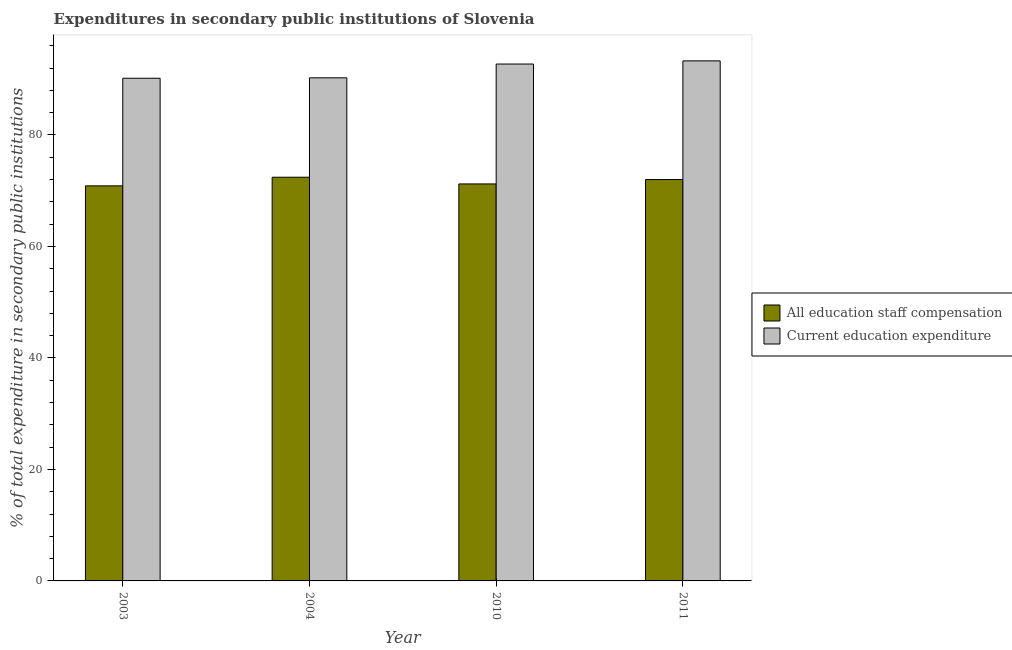How many bars are there on the 4th tick from the left?
Offer a terse response. 2. What is the label of the 2nd group of bars from the left?
Your response must be concise. 2004. In how many cases, is the number of bars for a given year not equal to the number of legend labels?
Your response must be concise. 0. What is the expenditure in staff compensation in 2010?
Your answer should be very brief. 71.22. Across all years, what is the maximum expenditure in education?
Give a very brief answer. 93.3. Across all years, what is the minimum expenditure in staff compensation?
Provide a short and direct response. 70.87. In which year was the expenditure in education maximum?
Your answer should be very brief. 2011. What is the total expenditure in education in the graph?
Your answer should be very brief. 366.46. What is the difference between the expenditure in staff compensation in 2003 and that in 2011?
Ensure brevity in your answer.  -1.14. What is the difference between the expenditure in education in 2003 and the expenditure in staff compensation in 2011?
Provide a short and direct response. -3.12. What is the average expenditure in staff compensation per year?
Make the answer very short. 71.63. In the year 2011, what is the difference between the expenditure in staff compensation and expenditure in education?
Make the answer very short. 0. What is the ratio of the expenditure in education in 2004 to that in 2011?
Provide a short and direct response. 0.97. What is the difference between the highest and the second highest expenditure in staff compensation?
Offer a very short reply. 0.42. What is the difference between the highest and the lowest expenditure in staff compensation?
Your answer should be very brief. 1.55. What does the 2nd bar from the left in 2010 represents?
Provide a short and direct response. Current education expenditure. What does the 1st bar from the right in 2003 represents?
Provide a short and direct response. Current education expenditure. Are all the bars in the graph horizontal?
Offer a very short reply. No. What is the difference between two consecutive major ticks on the Y-axis?
Provide a succinct answer. 20. Where does the legend appear in the graph?
Keep it short and to the point. Center right. How are the legend labels stacked?
Your answer should be very brief. Vertical. What is the title of the graph?
Offer a very short reply. Expenditures in secondary public institutions of Slovenia. What is the label or title of the X-axis?
Ensure brevity in your answer.  Year. What is the label or title of the Y-axis?
Make the answer very short. % of total expenditure in secondary public institutions. What is the % of total expenditure in secondary public institutions in All education staff compensation in 2003?
Your response must be concise. 70.87. What is the % of total expenditure in secondary public institutions in Current education expenditure in 2003?
Provide a short and direct response. 90.18. What is the % of total expenditure in secondary public institutions of All education staff compensation in 2004?
Your answer should be compact. 72.42. What is the % of total expenditure in secondary public institutions in Current education expenditure in 2004?
Make the answer very short. 90.26. What is the % of total expenditure in secondary public institutions of All education staff compensation in 2010?
Your response must be concise. 71.22. What is the % of total expenditure in secondary public institutions of Current education expenditure in 2010?
Provide a short and direct response. 92.73. What is the % of total expenditure in secondary public institutions in All education staff compensation in 2011?
Give a very brief answer. 72.01. What is the % of total expenditure in secondary public institutions in Current education expenditure in 2011?
Keep it short and to the point. 93.3. Across all years, what is the maximum % of total expenditure in secondary public institutions in All education staff compensation?
Make the answer very short. 72.42. Across all years, what is the maximum % of total expenditure in secondary public institutions in Current education expenditure?
Your response must be concise. 93.3. Across all years, what is the minimum % of total expenditure in secondary public institutions of All education staff compensation?
Ensure brevity in your answer.  70.87. Across all years, what is the minimum % of total expenditure in secondary public institutions in Current education expenditure?
Your answer should be very brief. 90.18. What is the total % of total expenditure in secondary public institutions of All education staff compensation in the graph?
Offer a very short reply. 286.52. What is the total % of total expenditure in secondary public institutions of Current education expenditure in the graph?
Ensure brevity in your answer.  366.46. What is the difference between the % of total expenditure in secondary public institutions in All education staff compensation in 2003 and that in 2004?
Provide a succinct answer. -1.55. What is the difference between the % of total expenditure in secondary public institutions in Current education expenditure in 2003 and that in 2004?
Your answer should be very brief. -0.08. What is the difference between the % of total expenditure in secondary public institutions of All education staff compensation in 2003 and that in 2010?
Offer a very short reply. -0.35. What is the difference between the % of total expenditure in secondary public institutions of Current education expenditure in 2003 and that in 2010?
Make the answer very short. -2.55. What is the difference between the % of total expenditure in secondary public institutions in All education staff compensation in 2003 and that in 2011?
Give a very brief answer. -1.14. What is the difference between the % of total expenditure in secondary public institutions in Current education expenditure in 2003 and that in 2011?
Your response must be concise. -3.12. What is the difference between the % of total expenditure in secondary public institutions in All education staff compensation in 2004 and that in 2010?
Offer a very short reply. 1.2. What is the difference between the % of total expenditure in secondary public institutions of Current education expenditure in 2004 and that in 2010?
Provide a succinct answer. -2.47. What is the difference between the % of total expenditure in secondary public institutions in All education staff compensation in 2004 and that in 2011?
Offer a very short reply. 0.42. What is the difference between the % of total expenditure in secondary public institutions in Current education expenditure in 2004 and that in 2011?
Provide a short and direct response. -3.04. What is the difference between the % of total expenditure in secondary public institutions of All education staff compensation in 2010 and that in 2011?
Your answer should be compact. -0.79. What is the difference between the % of total expenditure in secondary public institutions of Current education expenditure in 2010 and that in 2011?
Your response must be concise. -0.57. What is the difference between the % of total expenditure in secondary public institutions in All education staff compensation in 2003 and the % of total expenditure in secondary public institutions in Current education expenditure in 2004?
Keep it short and to the point. -19.38. What is the difference between the % of total expenditure in secondary public institutions of All education staff compensation in 2003 and the % of total expenditure in secondary public institutions of Current education expenditure in 2010?
Keep it short and to the point. -21.86. What is the difference between the % of total expenditure in secondary public institutions in All education staff compensation in 2003 and the % of total expenditure in secondary public institutions in Current education expenditure in 2011?
Give a very brief answer. -22.42. What is the difference between the % of total expenditure in secondary public institutions of All education staff compensation in 2004 and the % of total expenditure in secondary public institutions of Current education expenditure in 2010?
Make the answer very short. -20.3. What is the difference between the % of total expenditure in secondary public institutions of All education staff compensation in 2004 and the % of total expenditure in secondary public institutions of Current education expenditure in 2011?
Give a very brief answer. -20.87. What is the difference between the % of total expenditure in secondary public institutions in All education staff compensation in 2010 and the % of total expenditure in secondary public institutions in Current education expenditure in 2011?
Your response must be concise. -22.07. What is the average % of total expenditure in secondary public institutions of All education staff compensation per year?
Your response must be concise. 71.63. What is the average % of total expenditure in secondary public institutions in Current education expenditure per year?
Give a very brief answer. 91.61. In the year 2003, what is the difference between the % of total expenditure in secondary public institutions in All education staff compensation and % of total expenditure in secondary public institutions in Current education expenditure?
Keep it short and to the point. -19.31. In the year 2004, what is the difference between the % of total expenditure in secondary public institutions of All education staff compensation and % of total expenditure in secondary public institutions of Current education expenditure?
Your response must be concise. -17.83. In the year 2010, what is the difference between the % of total expenditure in secondary public institutions of All education staff compensation and % of total expenditure in secondary public institutions of Current education expenditure?
Provide a succinct answer. -21.51. In the year 2011, what is the difference between the % of total expenditure in secondary public institutions in All education staff compensation and % of total expenditure in secondary public institutions in Current education expenditure?
Provide a succinct answer. -21.29. What is the ratio of the % of total expenditure in secondary public institutions in All education staff compensation in 2003 to that in 2004?
Make the answer very short. 0.98. What is the ratio of the % of total expenditure in secondary public institutions in All education staff compensation in 2003 to that in 2010?
Keep it short and to the point. 1. What is the ratio of the % of total expenditure in secondary public institutions of Current education expenditure in 2003 to that in 2010?
Offer a very short reply. 0.97. What is the ratio of the % of total expenditure in secondary public institutions of All education staff compensation in 2003 to that in 2011?
Provide a succinct answer. 0.98. What is the ratio of the % of total expenditure in secondary public institutions in Current education expenditure in 2003 to that in 2011?
Offer a very short reply. 0.97. What is the ratio of the % of total expenditure in secondary public institutions of All education staff compensation in 2004 to that in 2010?
Your answer should be very brief. 1.02. What is the ratio of the % of total expenditure in secondary public institutions of Current education expenditure in 2004 to that in 2010?
Your answer should be very brief. 0.97. What is the ratio of the % of total expenditure in secondary public institutions of All education staff compensation in 2004 to that in 2011?
Offer a terse response. 1.01. What is the ratio of the % of total expenditure in secondary public institutions in Current education expenditure in 2004 to that in 2011?
Ensure brevity in your answer.  0.97. What is the ratio of the % of total expenditure in secondary public institutions in All education staff compensation in 2010 to that in 2011?
Your answer should be very brief. 0.99. What is the difference between the highest and the second highest % of total expenditure in secondary public institutions in All education staff compensation?
Provide a succinct answer. 0.42. What is the difference between the highest and the second highest % of total expenditure in secondary public institutions of Current education expenditure?
Provide a succinct answer. 0.57. What is the difference between the highest and the lowest % of total expenditure in secondary public institutions in All education staff compensation?
Ensure brevity in your answer.  1.55. What is the difference between the highest and the lowest % of total expenditure in secondary public institutions of Current education expenditure?
Offer a terse response. 3.12. 